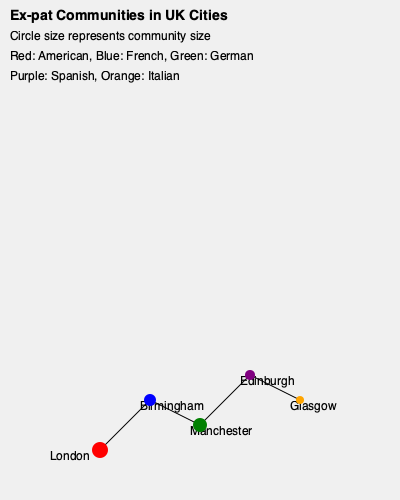Based on the map of ex-pat communities in UK cities, which city has the largest American ex-pat population, and how does it compare to the German ex-pat community in Manchester? To answer this question, we need to analyze the information provided in the map:

1. The map shows ex-pat communities in five UK cities: London, Birmingham, Manchester, Edinburgh, and Glasgow.
2. The size of the circles represents the size of the ex-pat communities.
3. Different colors represent different nationalities: Red for American, Green for German, and other colors for French, Spanish, and Italian.

4. Examining the red circles (American ex-pats):
   - London has the largest red circle, indicating the largest American ex-pat community.
   - Other cities have smaller or no visible red circles.

5. Comparing London's American community to Manchester's German community:
   - London's red circle (American) has a radius of 8 units.
   - Manchester's green circle (German) has a radius of 7 units.

6. To compare the sizes, we can use the formula for the area of a circle: $A = \pi r^2$
   - London (American): $A_L = \pi (8^2) = 64\pi$
   - Manchester (German): $A_M = \pi (7^2) = 49\pi$

7. Calculating the ratio:
   $\frac{A_L}{A_M} = \frac{64\pi}{49\pi} \approx 1.31$

Therefore, the American ex-pat community in London is approximately 1.31 times larger than the German ex-pat community in Manchester.
Answer: London; 1.31 times larger 